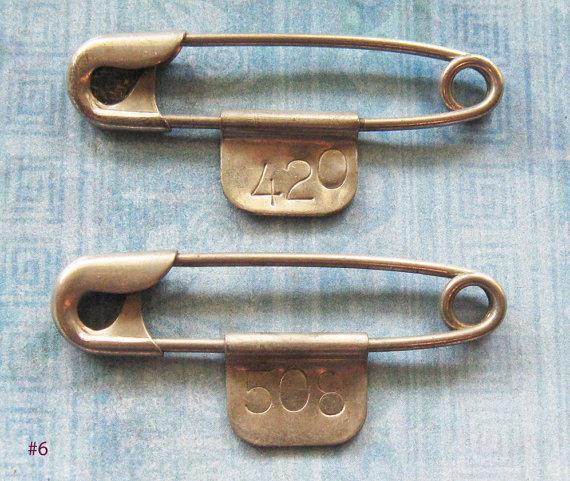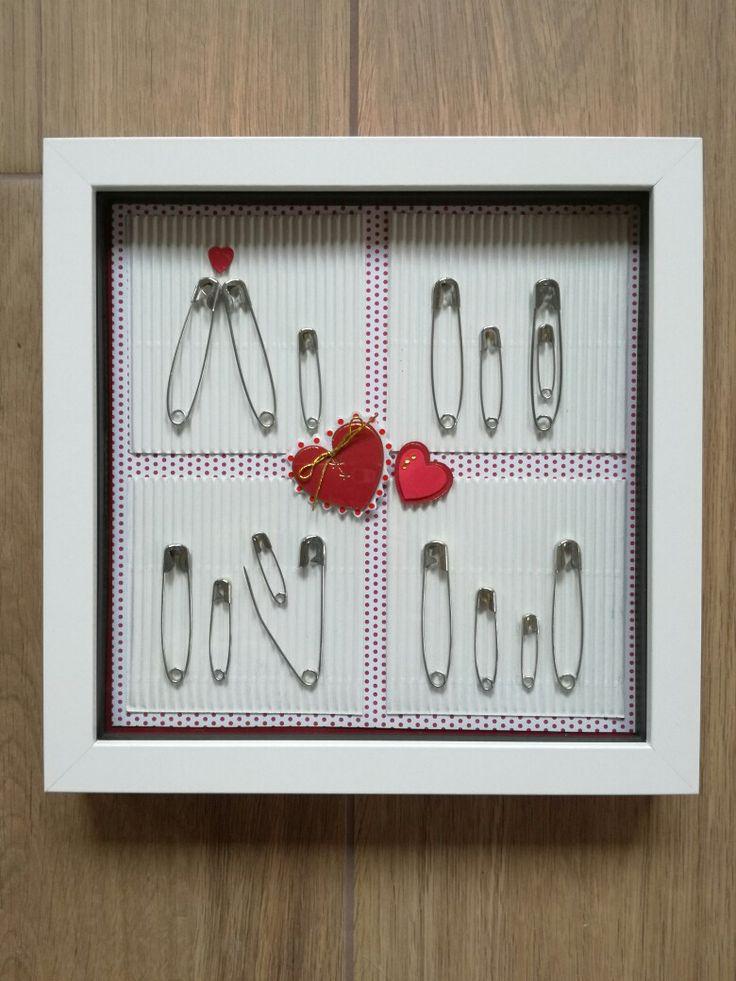The first image is the image on the left, the second image is the image on the right. Analyze the images presented: Is the assertion "One image contains exactly two gold-colored safety pins displayed horizontally." valid? Answer yes or no. Yes. 